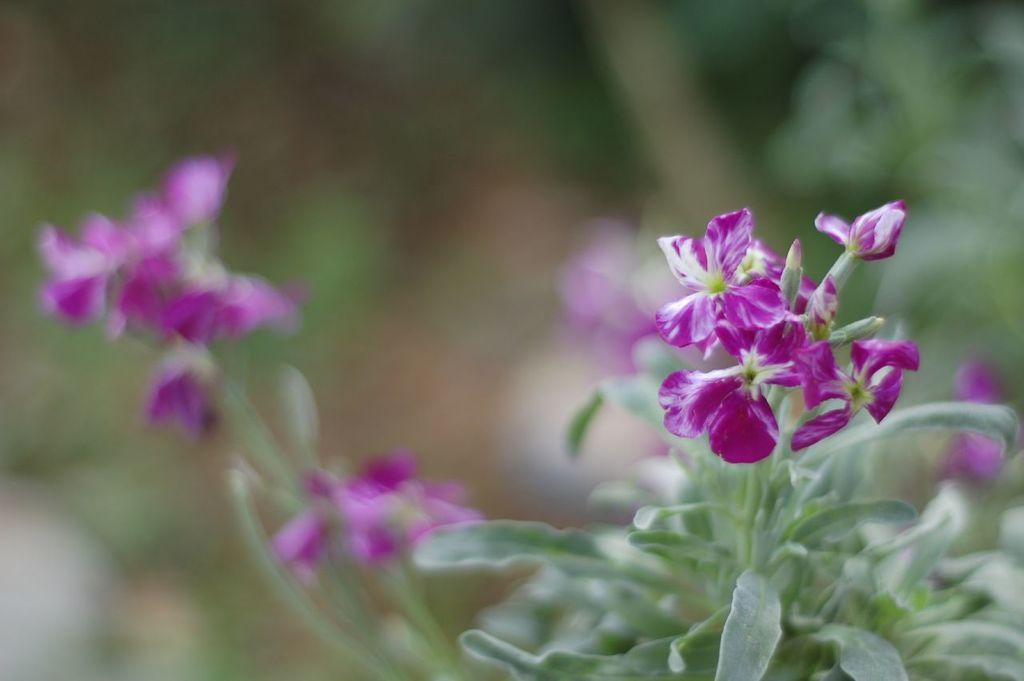What type of flowers can be seen in the foreground of the image? There are pink flowers in the foreground of the image. Are the flowers part of a larger plant or arrangement? Yes, the flowers are on plants. What other flowers can be seen on the plants? There are other flowers on the plants. Can you describe the background of the image? The background of the image is blurred. What type of books can be seen on the plants in the image? There are no books present in the image; it features pink flowers on plants. 